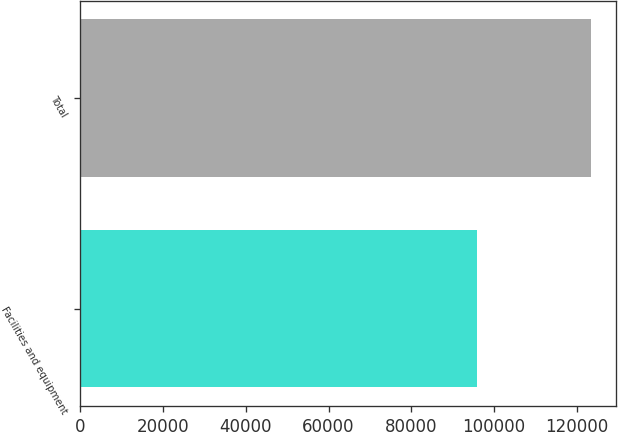Convert chart to OTSL. <chart><loc_0><loc_0><loc_500><loc_500><bar_chart><fcel>Facilities and equipment<fcel>Total<nl><fcel>95789<fcel>123388<nl></chart> 